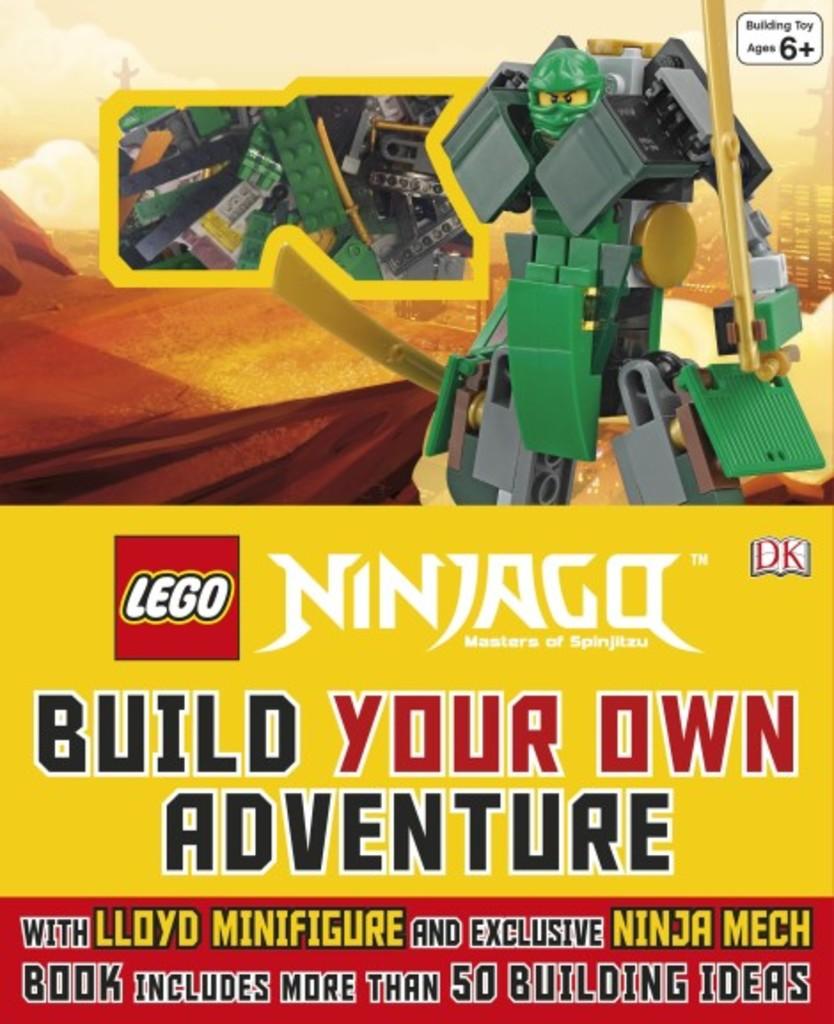What brand is this product?
Keep it short and to the point. Lego. What can you build?
Ensure brevity in your answer.  Your own adventure. 